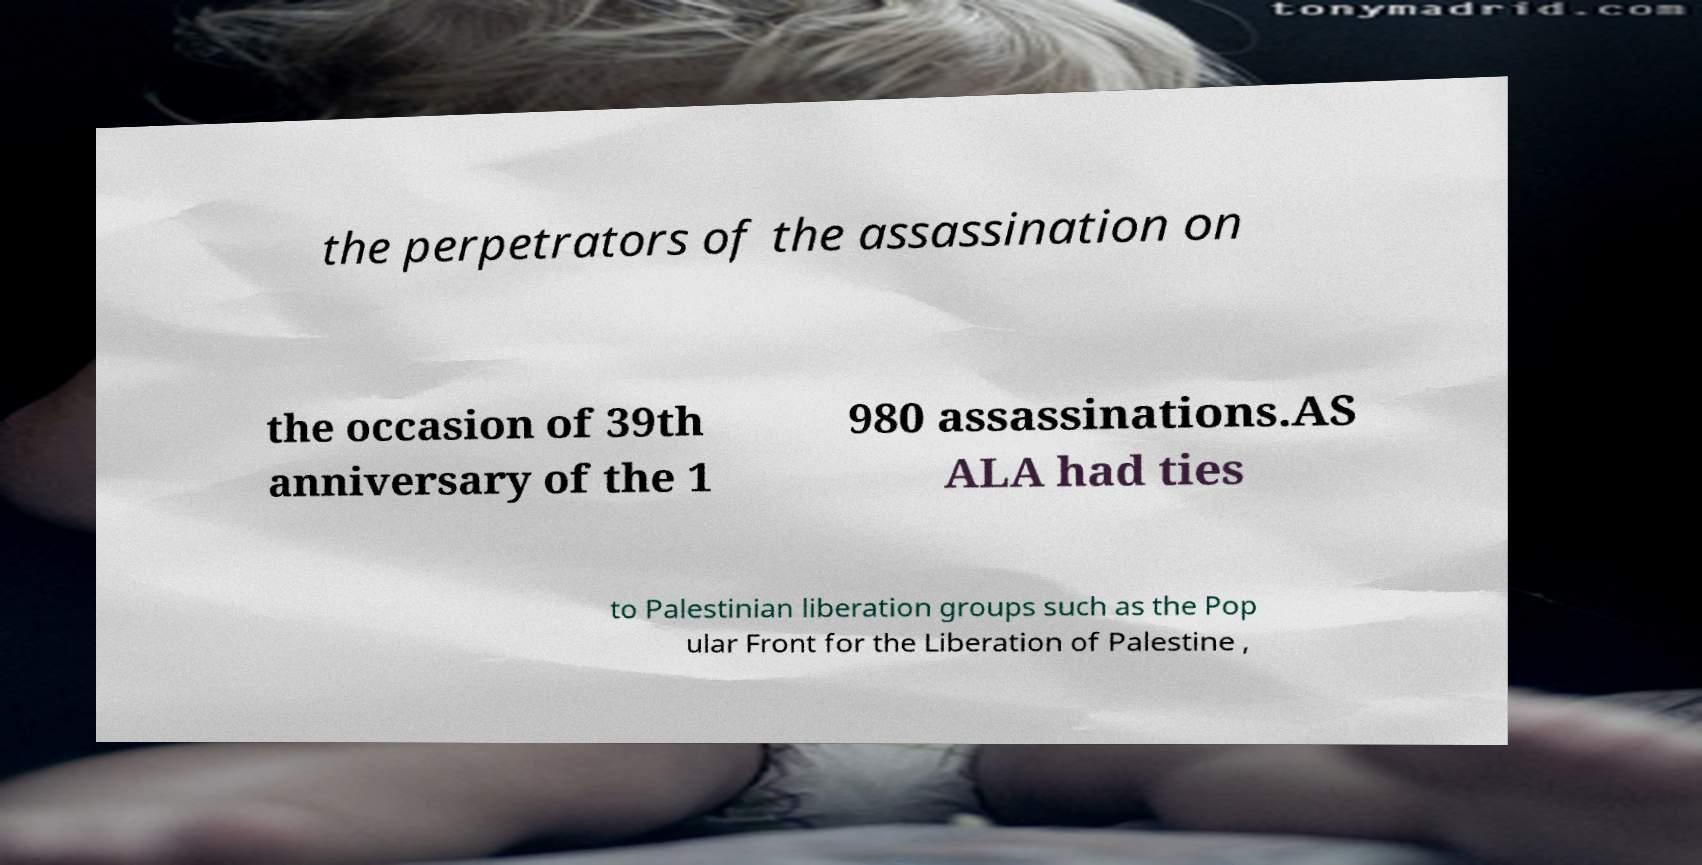I need the written content from this picture converted into text. Can you do that? the perpetrators of the assassination on the occasion of 39th anniversary of the 1 980 assassinations.AS ALA had ties to Palestinian liberation groups such as the Pop ular Front for the Liberation of Palestine , 